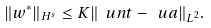Convert formula to latex. <formula><loc_0><loc_0><loc_500><loc_500>\| w ^ { * } \| _ { H ^ { s } } \leq K \| \ u n t - \ u a \| _ { L ^ { 2 } } .</formula> 